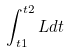<formula> <loc_0><loc_0><loc_500><loc_500>\int _ { t 1 } ^ { t 2 } L d t</formula> 